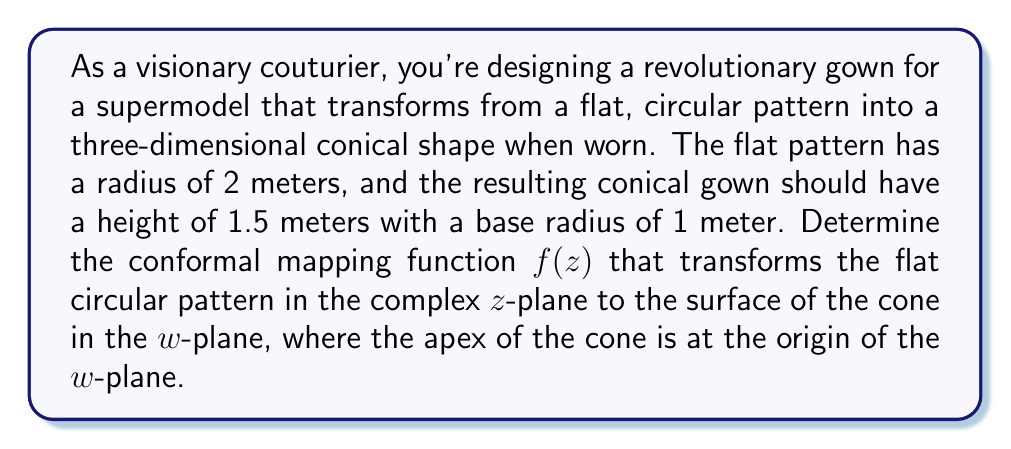Could you help me with this problem? To solve this problem, we need to follow these steps:

1) First, we need to recognize that the transformation from a flat circle to a cone surface is a logarithmic function. The general form of this conformal mapping is:

   $$w = f(z) = A \log(z) + B$$

   where A and B are complex constants we need to determine.

2) The flat pattern is a circle with radius 2 in the z-plane. We can represent this as:

   $$z = 2e^{i\theta}, \quad 0 \leq \theta < 2\pi$$

3) The cone in the w-plane can be represented in cylindrical coordinates $(r, \phi, h)$ as:

   $$r = \frac{h}{1.5}, \quad 0 \leq h \leq 1.5, \quad 0 \leq \phi < 2\pi$$

4) We want to map the outer edge of the circle ($|z| = 2$) to the base of the cone ($h = 1.5, r = 1$), and the center of the circle ($z = 0$) to the apex of the cone ($h = 0, r = 0$).

5) For the outer edge mapping:
   
   $$w = 1 + 1.5i \quad \text{when} \quad z = 2$$

6) Substituting into our general form:

   $$1 + 1.5i = A \log(2) + B$$

7) For the center mapping, as $z$ approaches 0, $\log(z)$ approaches negative infinity. To map this to the origin, we must have $A = ki$ where $k$ is a real constant. This ensures that as $\log(z)$ goes to $-\infty$, $w$ spirals towards 0.

8) The full rotation around the cone should correspond to a full rotation around the circle. This means:

   $$2\pi i = A(2\pi i)$$

   Therefore, $A = 1$.

9) Now we can solve for B:

   $$1 + 1.5i = \log(2) + B$$
   $$B = 1 + 1.5i - \log(2)$$

10) Therefore, our conformal mapping function is:

    $$w = f(z) = \log(z) + (1 + 1.5i - \log(2))$$

This function will map the flat circular pattern to the surface of the cone as required.
Answer: $$f(z) = \log(z) + (1 + 1.5i - \log(2))$$ 